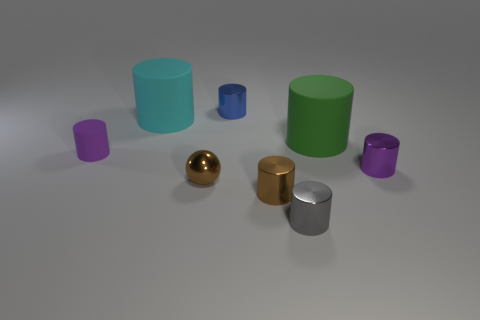What are similarities between the gold and silver objects? The gold and silver objects both have a cylindrical shape with a reflective surface. Their heights appear similar, making them comparable in those aspects. What could these objects represent in an artistic context? In an artistic context, these objects could represent themes of contrast and complementarity, with their differing colors embodying diversity and the similarity in shape hinting at unity. 